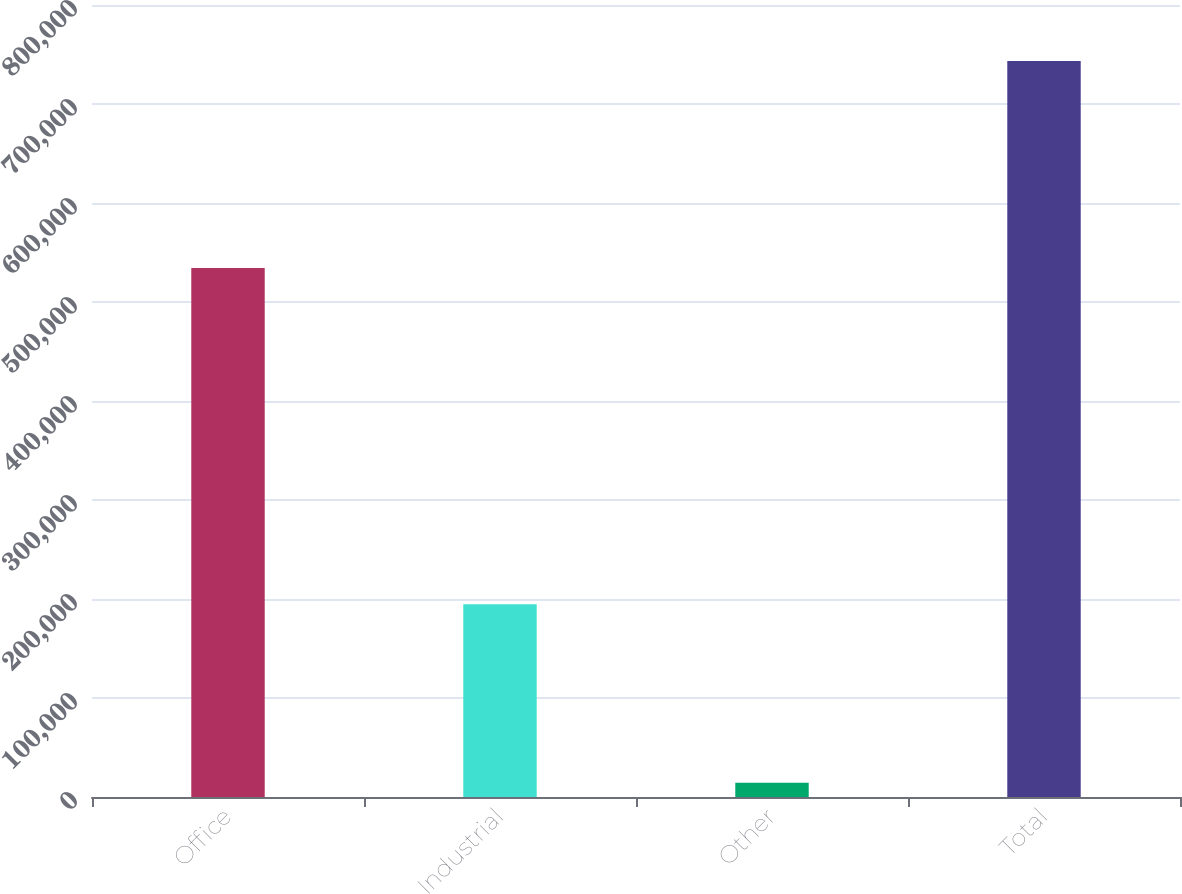Convert chart to OTSL. <chart><loc_0><loc_0><loc_500><loc_500><bar_chart><fcel>Office<fcel>Industrial<fcel>Other<fcel>Total<nl><fcel>534369<fcel>194670<fcel>14509<fcel>743548<nl></chart> 